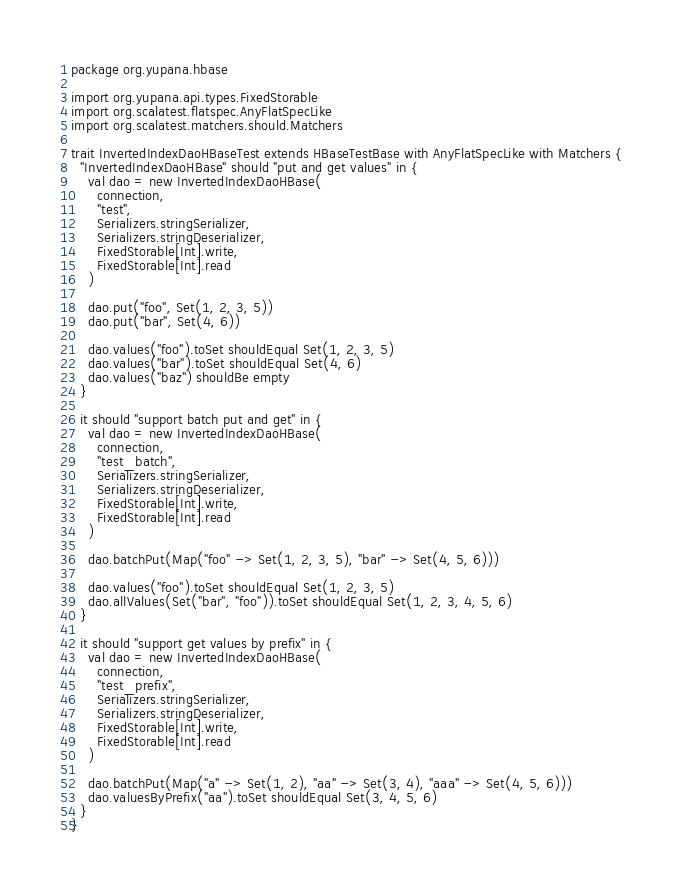Convert code to text. <code><loc_0><loc_0><loc_500><loc_500><_Scala_>package org.yupana.hbase

import org.yupana.api.types.FixedStorable
import org.scalatest.flatspec.AnyFlatSpecLike
import org.scalatest.matchers.should.Matchers

trait InvertedIndexDaoHBaseTest extends HBaseTestBase with AnyFlatSpecLike with Matchers {
  "InvertedIndexDaoHBase" should "put and get values" in {
    val dao = new InvertedIndexDaoHBase(
      connection,
      "test",
      Serializers.stringSerializer,
      Serializers.stringDeserializer,
      FixedStorable[Int].write,
      FixedStorable[Int].read
    )

    dao.put("foo", Set(1, 2, 3, 5))
    dao.put("bar", Set(4, 6))

    dao.values("foo").toSet shouldEqual Set(1, 2, 3, 5)
    dao.values("bar").toSet shouldEqual Set(4, 6)
    dao.values("baz") shouldBe empty
  }

  it should "support batch put and get" in {
    val dao = new InvertedIndexDaoHBase(
      connection,
      "test_batch",
      Serializers.stringSerializer,
      Serializers.stringDeserializer,
      FixedStorable[Int].write,
      FixedStorable[Int].read
    )

    dao.batchPut(Map("foo" -> Set(1, 2, 3, 5), "bar" -> Set(4, 5, 6)))

    dao.values("foo").toSet shouldEqual Set(1, 2, 3, 5)
    dao.allValues(Set("bar", "foo")).toSet shouldEqual Set(1, 2, 3, 4, 5, 6)
  }

  it should "support get values by prefix" in {
    val dao = new InvertedIndexDaoHBase(
      connection,
      "test_prefix",
      Serializers.stringSerializer,
      Serializers.stringDeserializer,
      FixedStorable[Int].write,
      FixedStorable[Int].read
    )

    dao.batchPut(Map("a" -> Set(1, 2), "aa" -> Set(3, 4), "aaa" -> Set(4, 5, 6)))
    dao.valuesByPrefix("aa").toSet shouldEqual Set(3, 4, 5, 6)
  }
}
</code> 